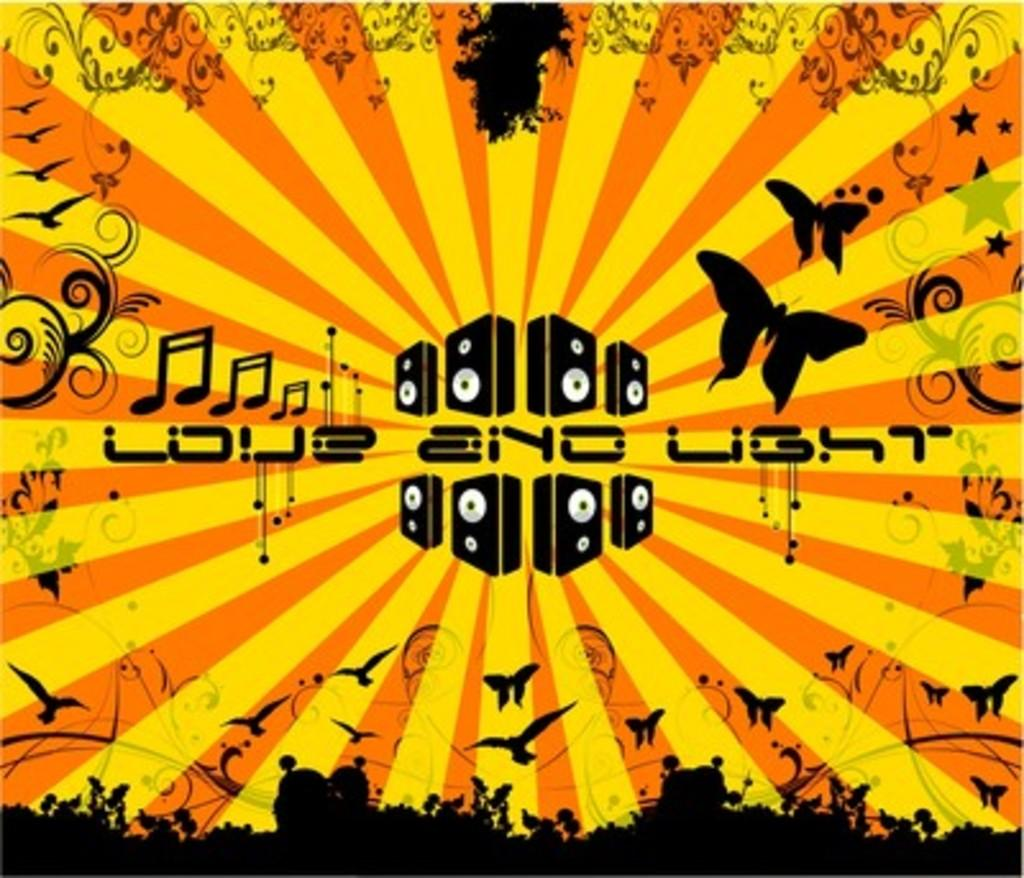<image>
Share a concise interpretation of the image provided. An orange and yellow poster that says Love end Light. 